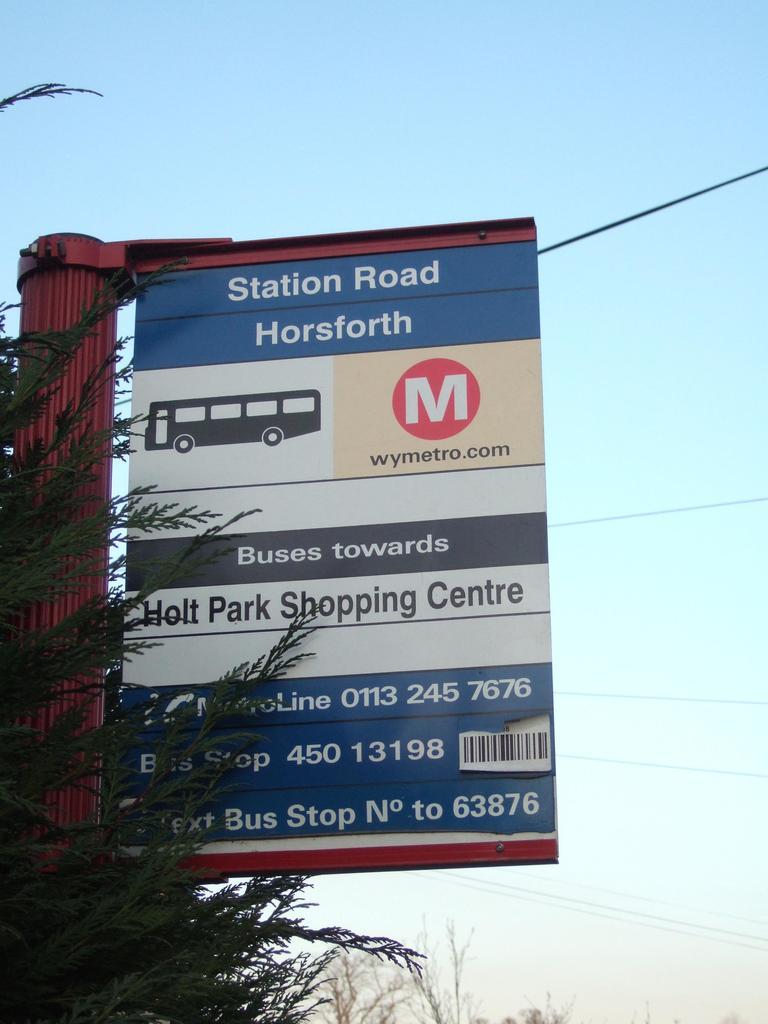What is the road called?
Offer a very short reply. Station road. 